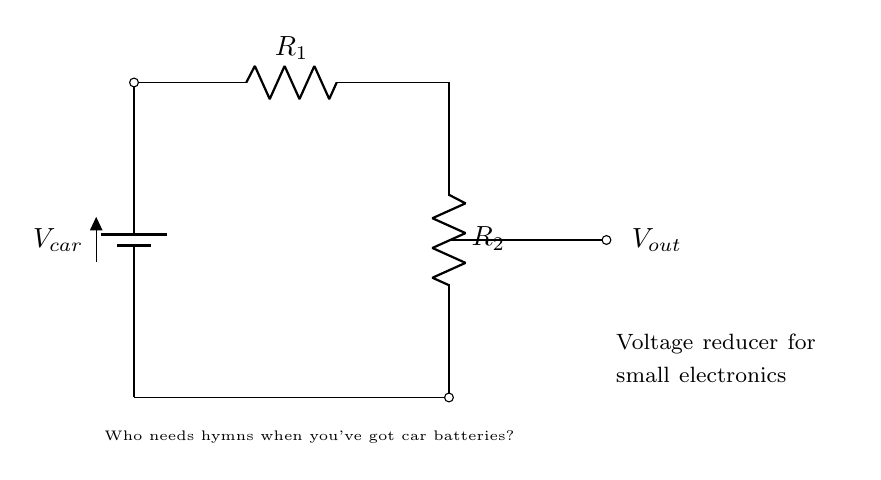What is the input voltage of the circuit? The input voltage, labeled as V car, is the voltage supplied by the car battery. It's referenced at the battery symbol in the diagram and is typically around 12 volts.
Answer: V car What are the resistances in the circuit? There are two resistors in the circuit, R 1 and R 2. The values for these resistors could vary, but they are typically specified based on the needs of the circuit's application.
Answer: R 1 and R 2 What is the purpose of this circuit? The purpose of this circuit, as indicated by the note, is to act as a voltage reducer for powering small electronics. It converts the higher voltage from the car battery to a lower voltage suitable for small devices.
Answer: Voltage reducer How would you find the output voltage in this circuit? The output voltage, V out, can be determined using the voltage divider formula, which relates the input voltage and the values of R 1 and R 2 to the output voltage. This involves calculating the voltage drop across R 2.
Answer: V out = (R 2 / (R 1 + R 2)) * V car Which resistor is closer to the output? R 2 is the resistor that is closest to the output point, as it is positioned directly before the output voltage node in the diagram.
Answer: R 2 What happens if R 1 is increased? If R 1 is increased, the output voltage, V out, will decrease as it changes the proportion of voltage drop across R 2 according to the voltage divider principle. This requires analyzing how R 1 and R 2 interact together in the voltage divider formula.
Answer: V out decreases 